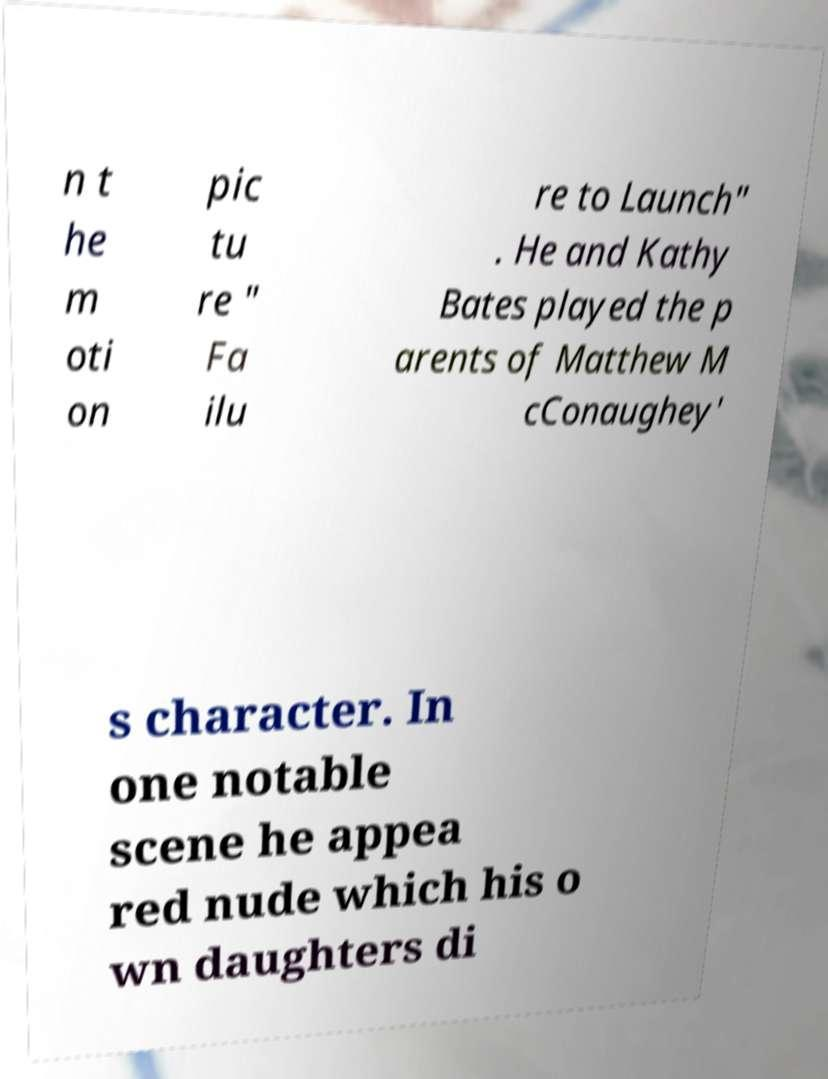For documentation purposes, I need the text within this image transcribed. Could you provide that? n t he m oti on pic tu re " Fa ilu re to Launch" . He and Kathy Bates played the p arents of Matthew M cConaughey' s character. In one notable scene he appea red nude which his o wn daughters di 